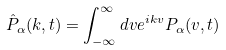Convert formula to latex. <formula><loc_0><loc_0><loc_500><loc_500>\hat { P } _ { \alpha } ( k , t ) = \int _ { - \infty } ^ { \infty } d v e ^ { i k v } P _ { \alpha } ( v , t )</formula> 